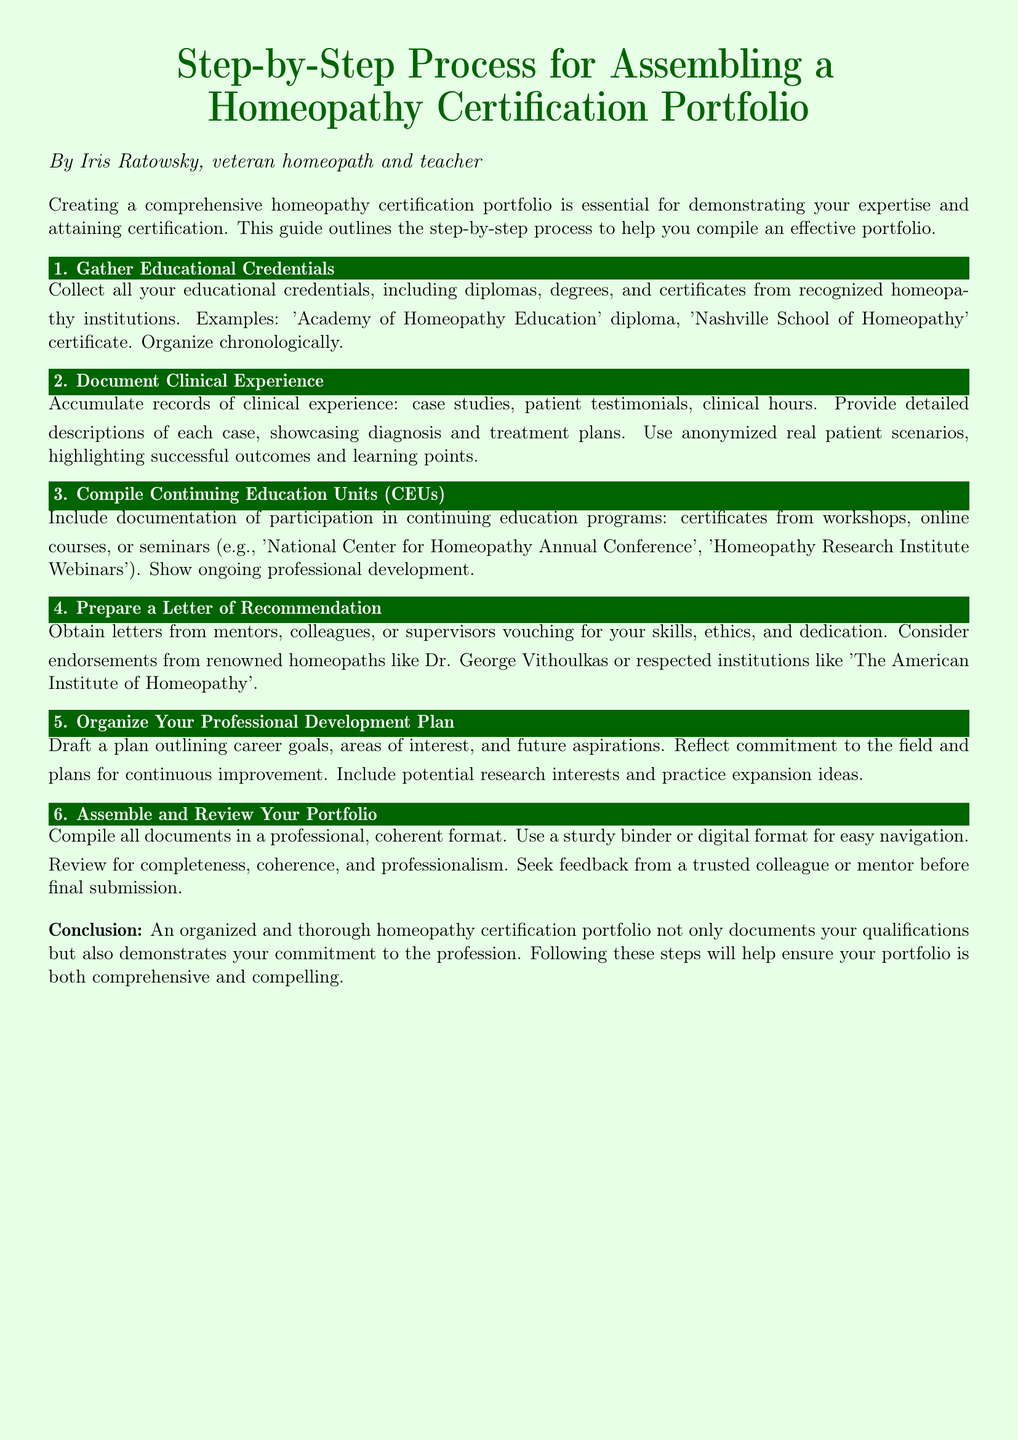What is the first step in assembling a Homeopathy Certification Portfolio? The first step is to gather all educational credentials.
Answer: Gather Educational Credentials What type of documents should be included in the clinical experience section? The clinical experience section should include case studies and patient testimonials.
Answer: Case studies, testimonies Which organization’s conference is mentioned as part of continuing education? The document refers to the National Center for Homeopathy Annual Conference.
Answer: National Center for Homeopathy What is the purpose of the professional development plan? The professional development plan outlines career goals and areas of interest.
Answer: Career goals, interests How should the portfolio be organized? The portfolio should be compiled in a professional, coherent format, either in a binder or digital format.
Answer: Professional format How many steps are outlined in the document for assembling the portfolio? The document outlines six steps in total for assembling the portfolio.
Answer: Six steps Which renowned homeopath's endorsement is suggested for the letter of recommendation? The document suggests endorsements from Dr. George Vithoulkas.
Answer: Dr. George Vithoulkas What is a crucial aspect that should be reviewed before final submission of the portfolio? The completeness and professionalism of the portfolio should be reviewed.
Answer: Completeness, professionalism 